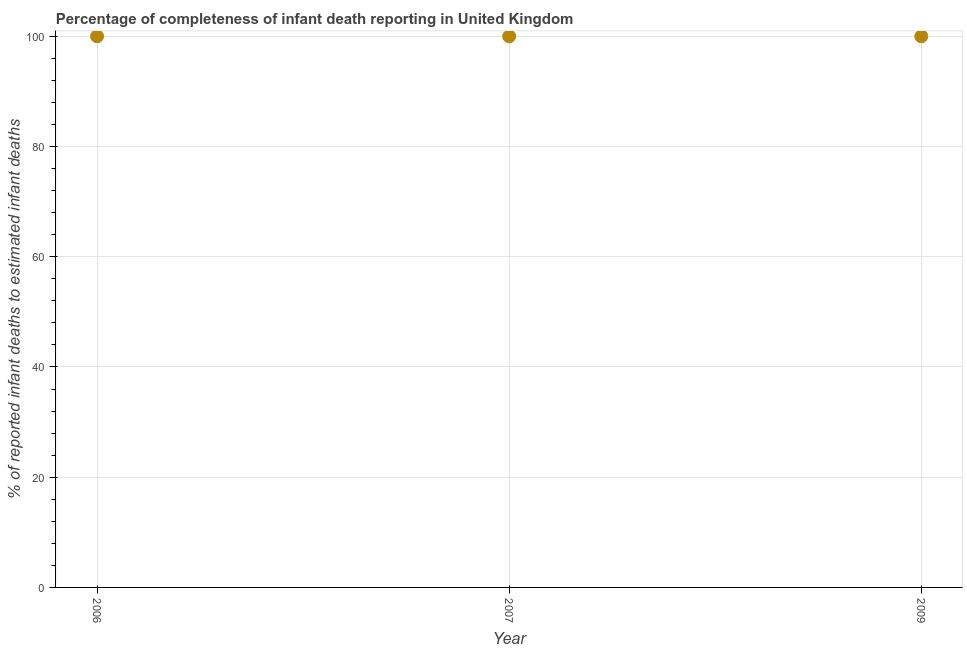What is the completeness of infant death reporting in 2009?
Your answer should be very brief. 100. Across all years, what is the maximum completeness of infant death reporting?
Keep it short and to the point. 100. Across all years, what is the minimum completeness of infant death reporting?
Offer a terse response. 100. In which year was the completeness of infant death reporting maximum?
Offer a terse response. 2006. What is the sum of the completeness of infant death reporting?
Keep it short and to the point. 300. What is the average completeness of infant death reporting per year?
Ensure brevity in your answer.  100. In how many years, is the completeness of infant death reporting greater than 52 %?
Your response must be concise. 3. Do a majority of the years between 2007 and 2006 (inclusive) have completeness of infant death reporting greater than 36 %?
Ensure brevity in your answer.  No. What is the ratio of the completeness of infant death reporting in 2006 to that in 2009?
Provide a succinct answer. 1. What is the difference between the highest and the second highest completeness of infant death reporting?
Your answer should be compact. 0. In how many years, is the completeness of infant death reporting greater than the average completeness of infant death reporting taken over all years?
Make the answer very short. 0. How many dotlines are there?
Your response must be concise. 1. How many years are there in the graph?
Your answer should be compact. 3. What is the difference between two consecutive major ticks on the Y-axis?
Your response must be concise. 20. Are the values on the major ticks of Y-axis written in scientific E-notation?
Offer a very short reply. No. Does the graph contain any zero values?
Offer a terse response. No. What is the title of the graph?
Make the answer very short. Percentage of completeness of infant death reporting in United Kingdom. What is the label or title of the X-axis?
Keep it short and to the point. Year. What is the label or title of the Y-axis?
Make the answer very short. % of reported infant deaths to estimated infant deaths. What is the % of reported infant deaths to estimated infant deaths in 2006?
Keep it short and to the point. 100. What is the % of reported infant deaths to estimated infant deaths in 2009?
Provide a succinct answer. 100. What is the difference between the % of reported infant deaths to estimated infant deaths in 2006 and 2007?
Keep it short and to the point. 0. What is the difference between the % of reported infant deaths to estimated infant deaths in 2006 and 2009?
Provide a succinct answer. 0. What is the difference between the % of reported infant deaths to estimated infant deaths in 2007 and 2009?
Your answer should be very brief. 0. What is the ratio of the % of reported infant deaths to estimated infant deaths in 2006 to that in 2007?
Your answer should be very brief. 1. 